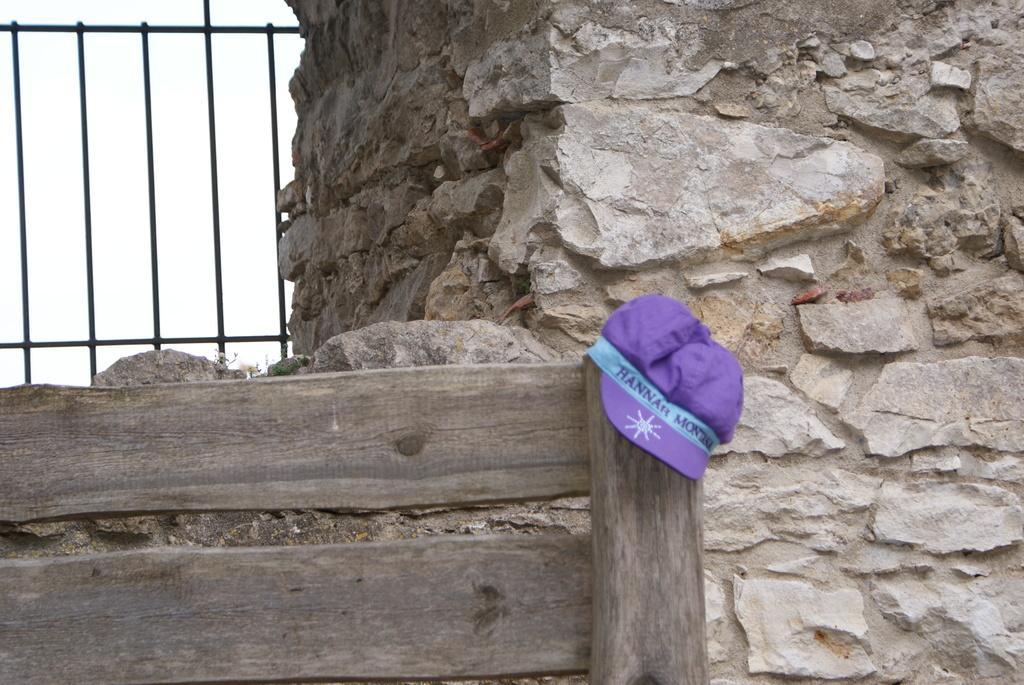Please provide a concise description of this image. In this image, we can see a rock wall. There is cap on the wood. There are grills in the top left of the image. 